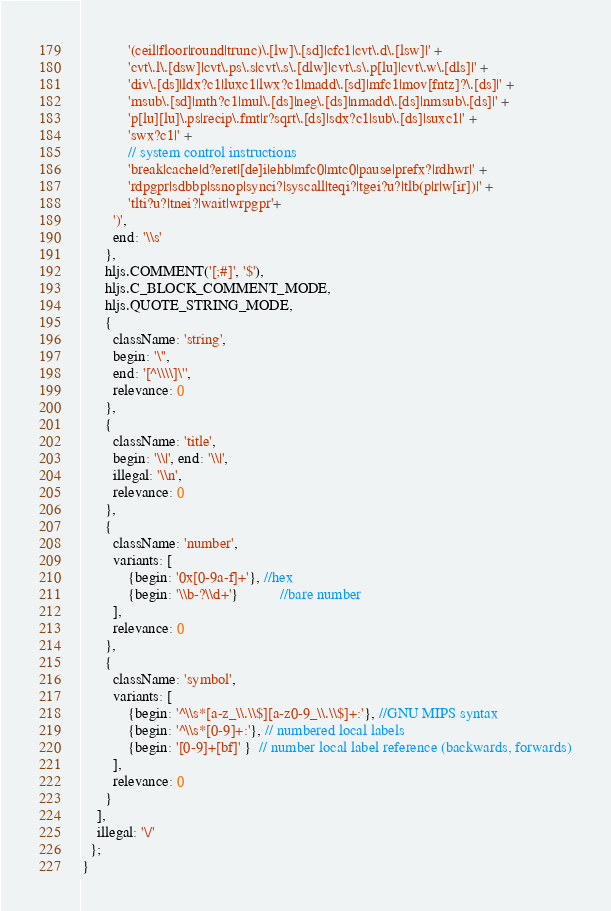Convert code to text. <code><loc_0><loc_0><loc_500><loc_500><_JavaScript_>            '(ceil|floor|round|trunc)\.[lw]\.[sd]|cfc1|cvt\.d\.[lsw]|' +
            'cvt\.l\.[dsw]|cvt\.ps\.s|cvt\.s\.[dlw]|cvt\.s\.p[lu]|cvt\.w\.[dls]|' +
            'div\.[ds]|ldx?c1|luxc1|lwx?c1|madd\.[sd]|mfc1|mov[fntz]?\.[ds]|' +
            'msub\.[sd]|mth?c1|mul\.[ds]|neg\.[ds]|nmadd\.[ds]|nmsub\.[ds]|' +
            'p[lu][lu]\.ps|recip\.fmt|r?sqrt\.[ds]|sdx?c1|sub\.[ds]|suxc1|' +
            'swx?c1|' +
            // system control instructions
            'break|cache|d?eret|[de]i|ehb|mfc0|mtc0|pause|prefx?|rdhwr|' +
            'rdpgpr|sdbbp|ssnop|synci?|syscall|teqi?|tgei?u?|tlb(p|r|w[ir])|' +
            'tlti?u?|tnei?|wait|wrpgpr'+
        ')',
        end: '\\s'
      },
      hljs.COMMENT('[;#]', '$'),
      hljs.C_BLOCK_COMMENT_MODE,
      hljs.QUOTE_STRING_MODE,
      {
        className: 'string',
        begin: '\'',
        end: '[^\\\\]\'',
        relevance: 0
      },
      {
        className: 'title',
        begin: '\\|', end: '\\|',
        illegal: '\\n',
        relevance: 0
      },
      {
        className: 'number',
        variants: [
            {begin: '0x[0-9a-f]+'}, //hex
            {begin: '\\b-?\\d+'}           //bare number
        ],
        relevance: 0
      },
      {
        className: 'symbol',
        variants: [
            {begin: '^\\s*[a-z_\\.\\$][a-z0-9_\\.\\$]+:'}, //GNU MIPS syntax
            {begin: '^\\s*[0-9]+:'}, // numbered local labels
            {begin: '[0-9]+[bf]' }  // number local label reference (backwards, forwards)
        ],
        relevance: 0
      }
    ],
    illegal: '\/'
  };
}
</code> 